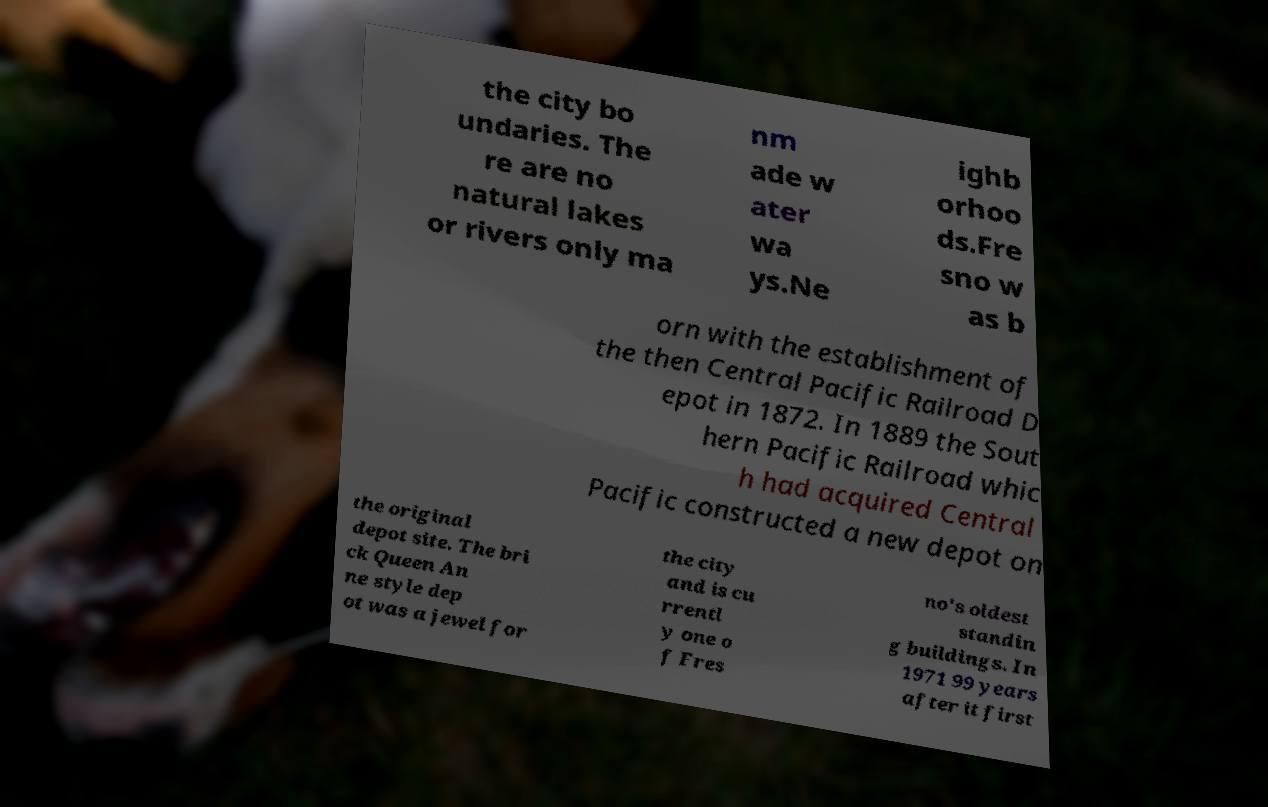I need the written content from this picture converted into text. Can you do that? the city bo undaries. The re are no natural lakes or rivers only ma nm ade w ater wa ys.Ne ighb orhoo ds.Fre sno w as b orn with the establishment of the then Central Pacific Railroad D epot in 1872. In 1889 the Sout hern Pacific Railroad whic h had acquired Central Pacific constructed a new depot on the original depot site. The bri ck Queen An ne style dep ot was a jewel for the city and is cu rrentl y one o f Fres no's oldest standin g buildings. In 1971 99 years after it first 